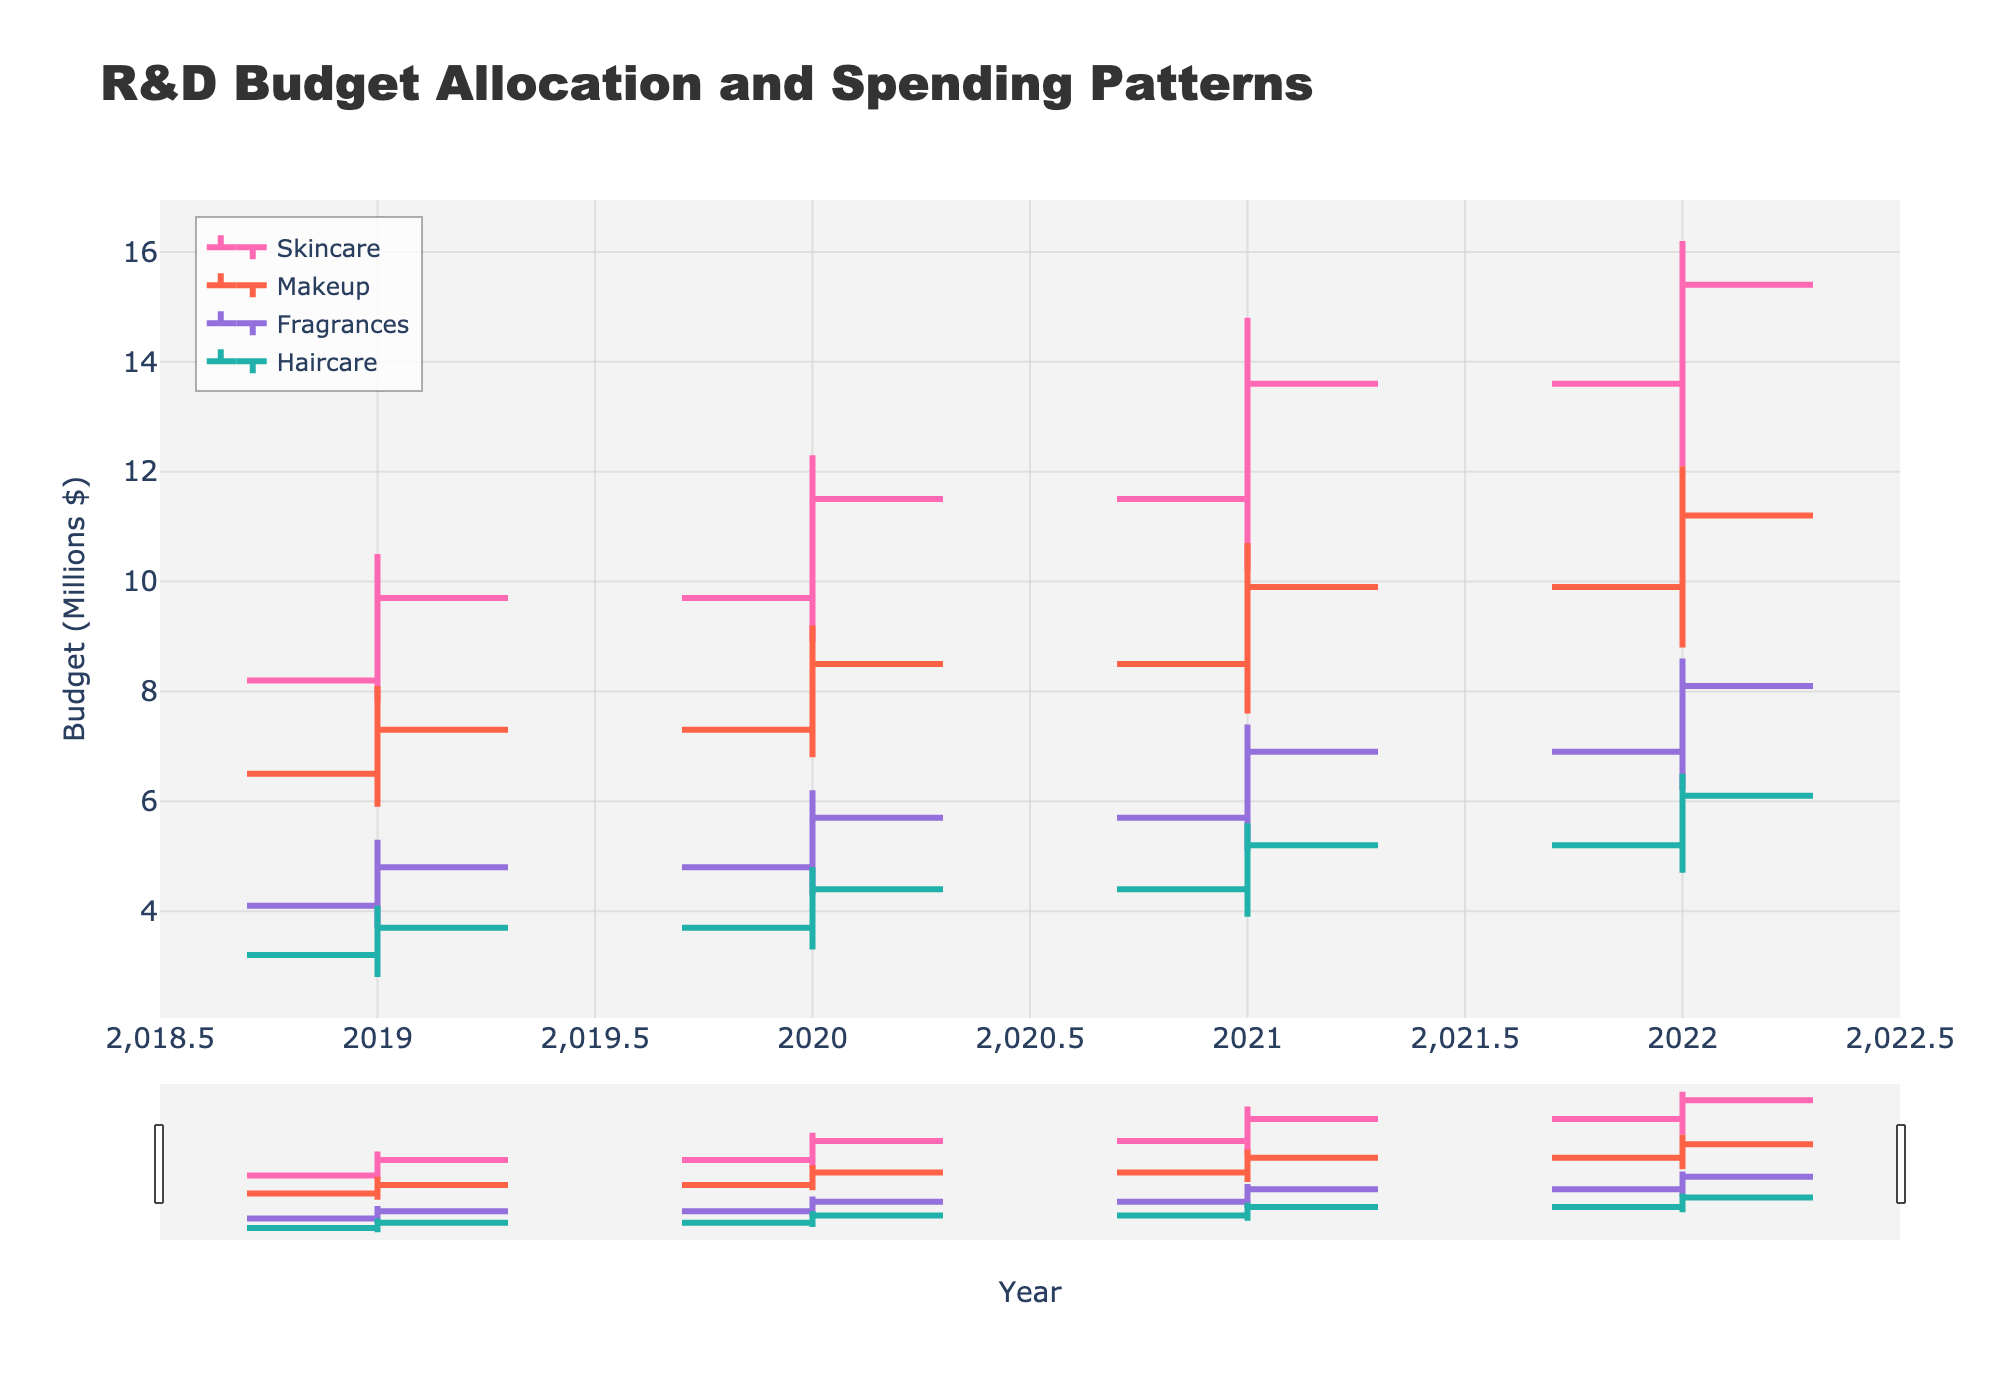What is the title of the figure? The title is prominently displayed at the top of the figure and reads 'R&D Budget Allocation and Spending Patterns'.
Answer: R&D Budget Allocation and Spending Patterns What is the overall trend of the Skincare budget allocation from 2019 to 2022? The Skincare budget allocation shows an upward trend. It starts at $8.2 million in 2019 and increases to $13.6 million by 2022.
Answer: Upward Among the product lines, which one had the highest budget in any given year? By observing the high points in the OHLC charts for each product line over the displayed years, we can see that Skincare had the highest peak budget of $16.2 million in 2022.
Answer: Skincare in 2022 Which product line showed the most significant percentage increase in budget allocation from 2019 to 2022? To determine the percentage increase, we need to calculate the relative change for each product line from their respective 2019 to 2022 values and then compare them. The Haircare budget increased from $3.2 million in 2019 to $5.2 million in 2022, about 93.75%. This increases more in relative terms than other product lines.
Answer: Haircare Was the Makeup budget allocation ever lower at the end of a year compared to the start of that year? By examining the OHLC data for Makeup, there is no instance where the closing budget is lower than the opening budget for any of the years provided.
Answer: No What can be inferred about the volatility in the Fragrances budget between 2019 and 2022? The range between the high and low points of Fragrances reflects moderate volatility. Still, it is not as high as the Skincare and Makeup lines, indicating more stable spending patterns.
Answer: Moderate volatility Which year showed the largest gap between the opening and closing budgets for Skincare? In the year 2020, the difference between the opening and closing budgets for Skincare was 1.8 (Open: 9.7, Close: 11.5), the largest viewed gap in amounts.
Answer: 2020 Of the product lines shown, which had the lowest starting budget allocation in 2019? By looking at the 'Open' values for 2019, Haircare had the lowest starting budget allocation of $3.2 million.
Answer: Haircare How does the budget trend for Haircare from 2019 to 2022 compare to Fragrances? Both product lines show an upward trend in budget allocation; however, Haircare started lower and showed steadier growth from $3.2 to $5.2 million, while Fragrances grew from $4.1 to $6.9 milion.
Answer: Upward for both, steadier for Haircare 